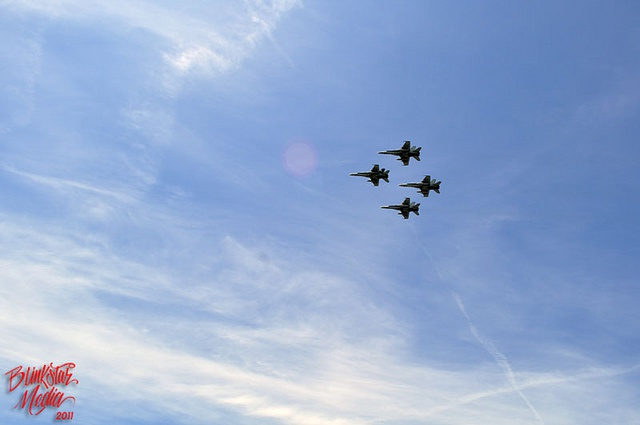Describe the objects in this image and their specific colors. I can see airplane in lavender, black, darkgray, and gray tones, airplane in lavender, black, gray, and darkgray tones, airplane in lavender, black, purple, gray, and darkgray tones, and airplane in lavender, black, gray, and darkgray tones in this image. 